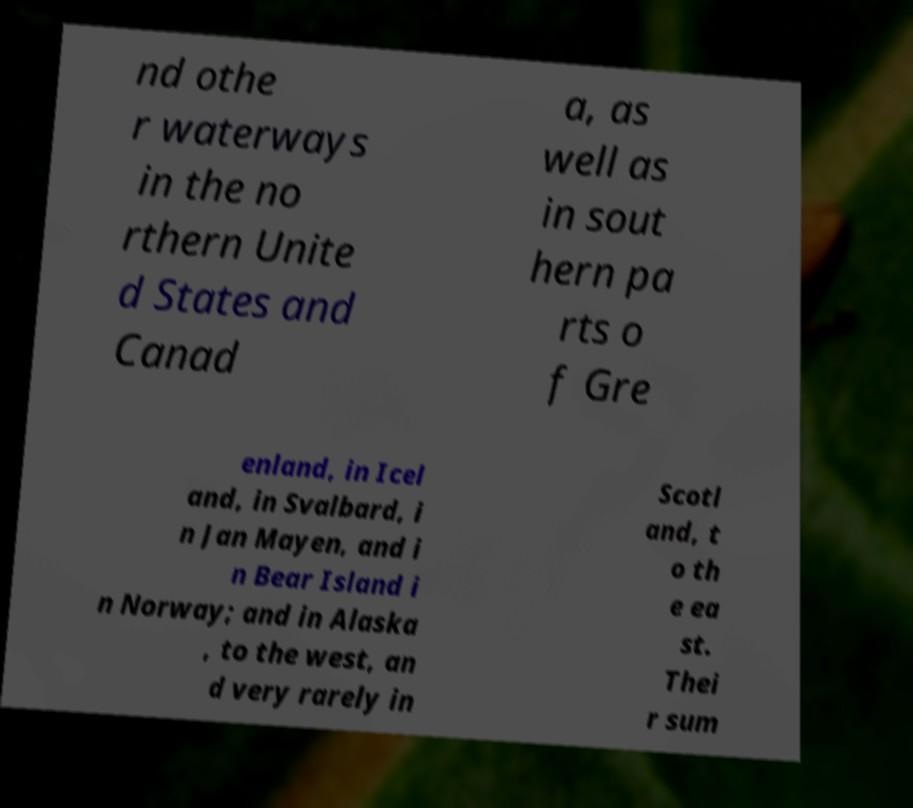There's text embedded in this image that I need extracted. Can you transcribe it verbatim? nd othe r waterways in the no rthern Unite d States and Canad a, as well as in sout hern pa rts o f Gre enland, in Icel and, in Svalbard, i n Jan Mayen, and i n Bear Island i n Norway; and in Alaska , to the west, an d very rarely in Scotl and, t o th e ea st. Thei r sum 